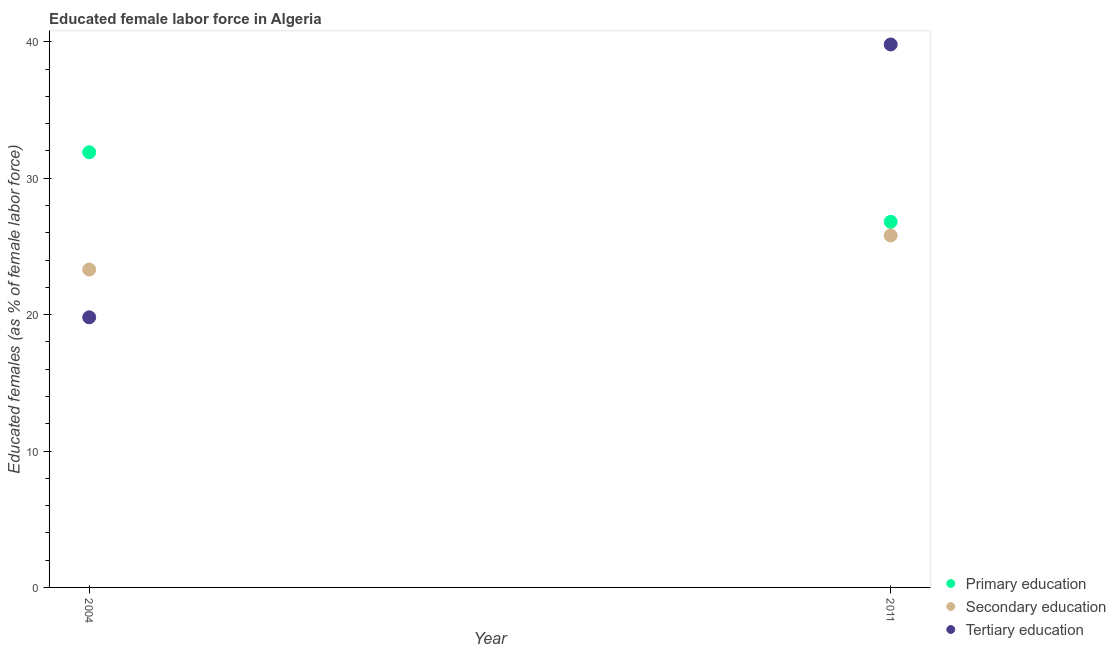How many different coloured dotlines are there?
Your answer should be compact. 3. Is the number of dotlines equal to the number of legend labels?
Offer a very short reply. Yes. What is the percentage of female labor force who received primary education in 2004?
Keep it short and to the point. 31.9. Across all years, what is the maximum percentage of female labor force who received secondary education?
Your response must be concise. 25.8. Across all years, what is the minimum percentage of female labor force who received secondary education?
Provide a short and direct response. 23.3. What is the total percentage of female labor force who received tertiary education in the graph?
Provide a succinct answer. 59.6. What is the average percentage of female labor force who received tertiary education per year?
Offer a terse response. 29.8. In the year 2004, what is the difference between the percentage of female labor force who received primary education and percentage of female labor force who received secondary education?
Give a very brief answer. 8.6. In how many years, is the percentage of female labor force who received tertiary education greater than 14 %?
Your response must be concise. 2. What is the ratio of the percentage of female labor force who received primary education in 2004 to that in 2011?
Give a very brief answer. 1.19. Is the percentage of female labor force who received tertiary education in 2004 less than that in 2011?
Keep it short and to the point. Yes. Is it the case that in every year, the sum of the percentage of female labor force who received primary education and percentage of female labor force who received secondary education is greater than the percentage of female labor force who received tertiary education?
Offer a very short reply. Yes. Is the percentage of female labor force who received tertiary education strictly less than the percentage of female labor force who received secondary education over the years?
Provide a succinct answer. No. How many dotlines are there?
Provide a succinct answer. 3. What is the difference between two consecutive major ticks on the Y-axis?
Your answer should be very brief. 10. Does the graph contain any zero values?
Your answer should be compact. No. Does the graph contain grids?
Your answer should be very brief. No. How many legend labels are there?
Ensure brevity in your answer.  3. What is the title of the graph?
Ensure brevity in your answer.  Educated female labor force in Algeria. What is the label or title of the X-axis?
Make the answer very short. Year. What is the label or title of the Y-axis?
Offer a terse response. Educated females (as % of female labor force). What is the Educated females (as % of female labor force) in Primary education in 2004?
Give a very brief answer. 31.9. What is the Educated females (as % of female labor force) of Secondary education in 2004?
Your answer should be very brief. 23.3. What is the Educated females (as % of female labor force) in Tertiary education in 2004?
Offer a very short reply. 19.8. What is the Educated females (as % of female labor force) in Primary education in 2011?
Offer a terse response. 26.8. What is the Educated females (as % of female labor force) in Secondary education in 2011?
Offer a terse response. 25.8. What is the Educated females (as % of female labor force) of Tertiary education in 2011?
Provide a short and direct response. 39.8. Across all years, what is the maximum Educated females (as % of female labor force) of Primary education?
Make the answer very short. 31.9. Across all years, what is the maximum Educated females (as % of female labor force) in Secondary education?
Make the answer very short. 25.8. Across all years, what is the maximum Educated females (as % of female labor force) in Tertiary education?
Offer a very short reply. 39.8. Across all years, what is the minimum Educated females (as % of female labor force) of Primary education?
Your response must be concise. 26.8. Across all years, what is the minimum Educated females (as % of female labor force) of Secondary education?
Keep it short and to the point. 23.3. Across all years, what is the minimum Educated females (as % of female labor force) in Tertiary education?
Ensure brevity in your answer.  19.8. What is the total Educated females (as % of female labor force) in Primary education in the graph?
Ensure brevity in your answer.  58.7. What is the total Educated females (as % of female labor force) in Secondary education in the graph?
Ensure brevity in your answer.  49.1. What is the total Educated females (as % of female labor force) of Tertiary education in the graph?
Give a very brief answer. 59.6. What is the difference between the Educated females (as % of female labor force) in Primary education in 2004 and that in 2011?
Your answer should be very brief. 5.1. What is the difference between the Educated females (as % of female labor force) of Tertiary education in 2004 and that in 2011?
Your response must be concise. -20. What is the difference between the Educated females (as % of female labor force) of Primary education in 2004 and the Educated females (as % of female labor force) of Secondary education in 2011?
Your answer should be compact. 6.1. What is the difference between the Educated females (as % of female labor force) of Secondary education in 2004 and the Educated females (as % of female labor force) of Tertiary education in 2011?
Your answer should be very brief. -16.5. What is the average Educated females (as % of female labor force) of Primary education per year?
Your answer should be very brief. 29.35. What is the average Educated females (as % of female labor force) in Secondary education per year?
Make the answer very short. 24.55. What is the average Educated females (as % of female labor force) in Tertiary education per year?
Give a very brief answer. 29.8. In the year 2004, what is the difference between the Educated females (as % of female labor force) of Primary education and Educated females (as % of female labor force) of Secondary education?
Provide a short and direct response. 8.6. In the year 2004, what is the difference between the Educated females (as % of female labor force) of Primary education and Educated females (as % of female labor force) of Tertiary education?
Provide a short and direct response. 12.1. In the year 2011, what is the difference between the Educated females (as % of female labor force) in Primary education and Educated females (as % of female labor force) in Tertiary education?
Your response must be concise. -13. What is the ratio of the Educated females (as % of female labor force) of Primary education in 2004 to that in 2011?
Make the answer very short. 1.19. What is the ratio of the Educated females (as % of female labor force) of Secondary education in 2004 to that in 2011?
Offer a very short reply. 0.9. What is the ratio of the Educated females (as % of female labor force) in Tertiary education in 2004 to that in 2011?
Your response must be concise. 0.5. What is the difference between the highest and the second highest Educated females (as % of female labor force) of Primary education?
Offer a very short reply. 5.1. What is the difference between the highest and the second highest Educated females (as % of female labor force) of Secondary education?
Your response must be concise. 2.5. What is the difference between the highest and the lowest Educated females (as % of female labor force) in Tertiary education?
Offer a terse response. 20. 